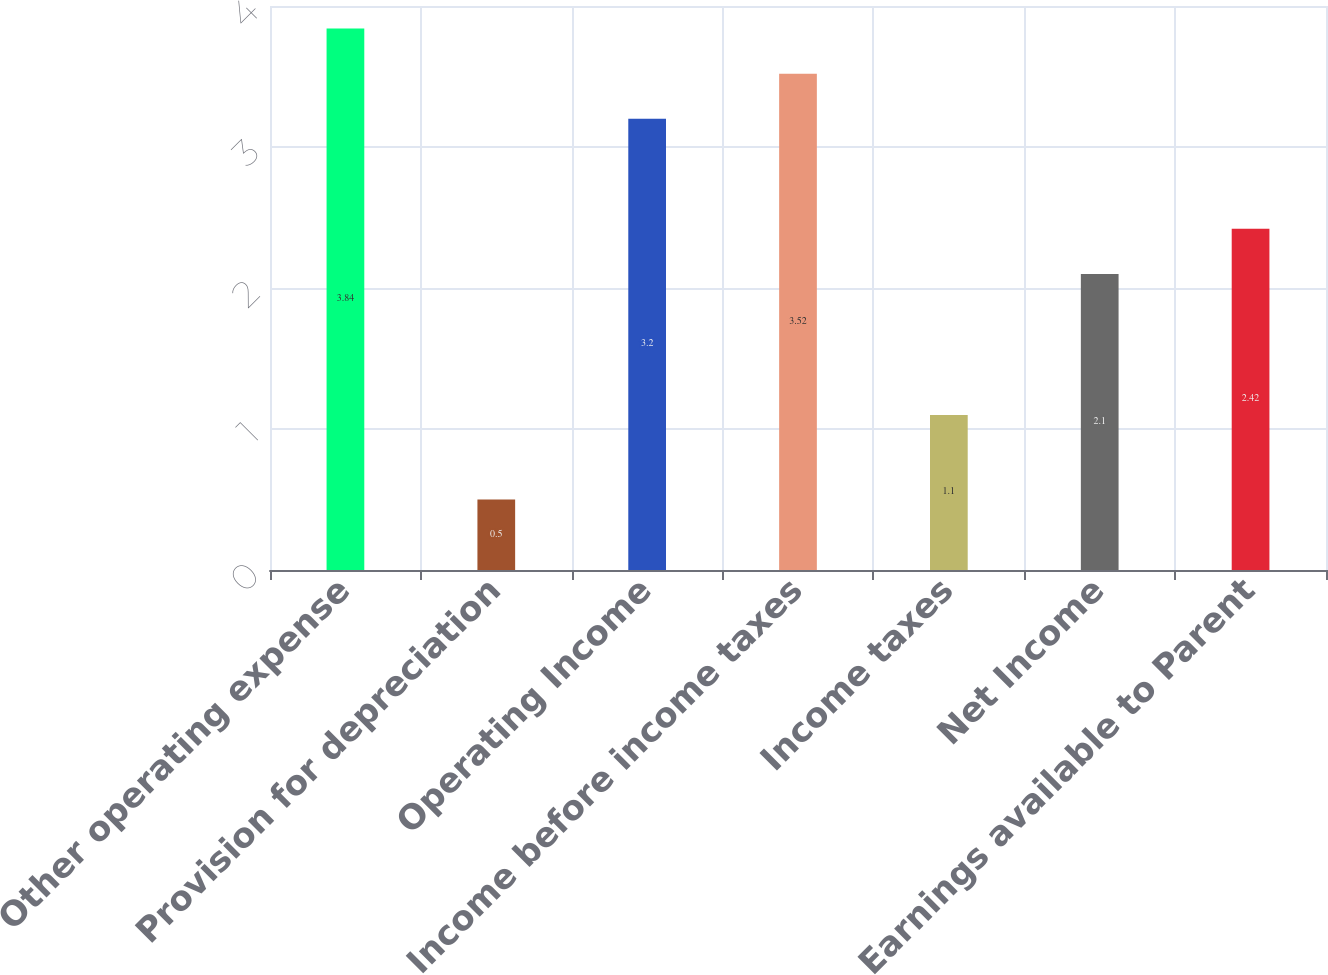Convert chart to OTSL. <chart><loc_0><loc_0><loc_500><loc_500><bar_chart><fcel>Other operating expense<fcel>Provision for depreciation<fcel>Operating Income<fcel>Income before income taxes<fcel>Income taxes<fcel>Net Income<fcel>Earnings available to Parent<nl><fcel>3.84<fcel>0.5<fcel>3.2<fcel>3.52<fcel>1.1<fcel>2.1<fcel>2.42<nl></chart> 